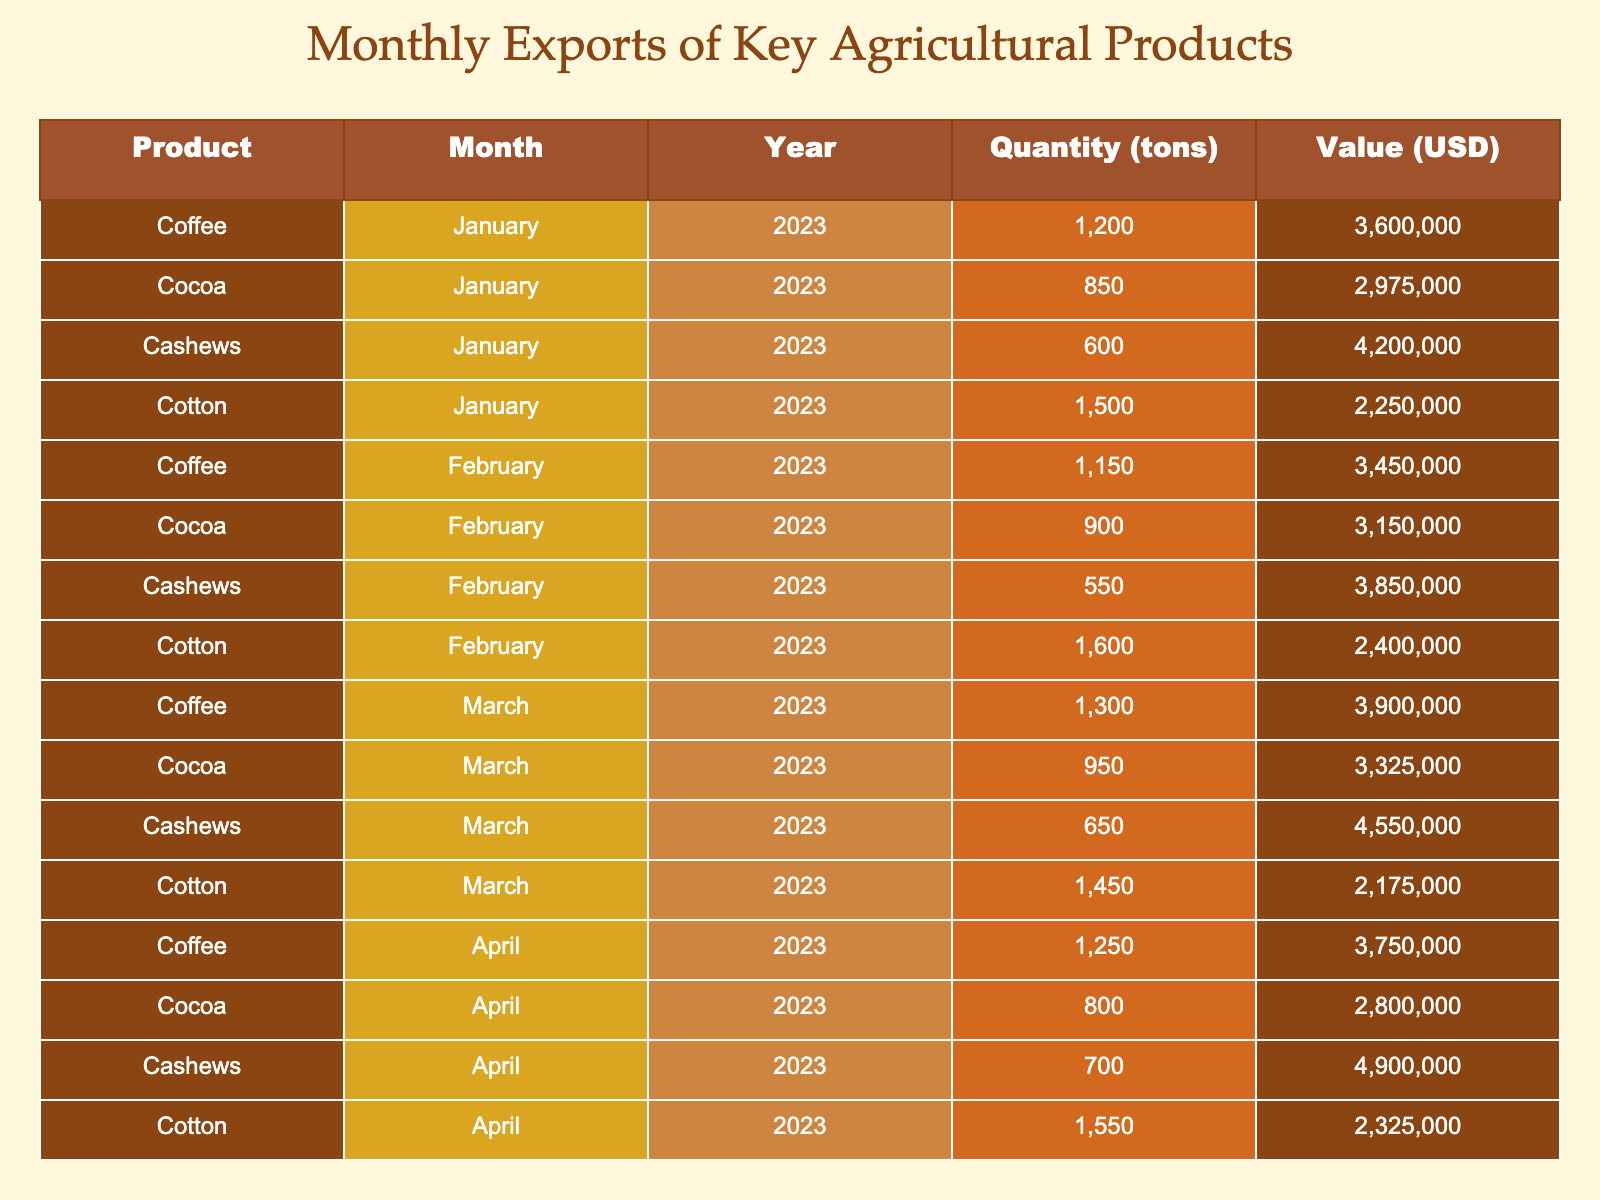What was the total quantity of coffee exported in January 2023? The quantity of coffee exported in January 2023 is listed as 1200 tons.
Answer: 1200 tons What was the total value of cashews exported in February 2023? The value of cashews exported in February 2023 is shown as 3850000 USD.
Answer: 3850000 USD Which month had the highest export value for cocoa? By comparing the value of cocoa across the months, March 2023 shows the highest value at 3325000 USD.
Answer: March 2023 What was the average quantity of cotton exported from January to May 2023? The quantities for cotton are 1500, 1600, 1450, 1550, and 1400. Summing these gives 1500 + 1600 + 1450 + 1550 + 1400 = 7500 tons, and averaging gives 7500 / 5 = 1500 tons.
Answer: 1500 tons Did cashew exports increase from January to May 2023? Observing the monthly cashew quantities: 600 in January, 550 in February, 650 in March, 700 in April, and 580 in May, there is variation, but the exports do not consistently increase; they rise from March to April.
Answer: No What is the total value of all coffee exports from January to April 2023? Adding the values for coffee from these months: 3600000 + 3450000 + 3900000 + 3750000 = 14700000 USD.
Answer: 14700000 USD Which product had the highest total quantity exported over the five months? The total quantities for each product are: Coffee = 1200 + 1150 + 1300 + 1250 + 1100 = 6050 tons, Cocoa = 850 + 900 + 950 + 800 + 920 = 4420 tons, Cashews = 600 + 550 + 650 + 700 + 580 = 3080 tons, Cotton = 1500 + 1600 + 1450 + 1550 + 1400 = 7500 tons. Therefore, cotton had the highest total with 7500 tons.
Answer: Cotton In which month were the exports of all products combined at their lowest? By summing up the exports for each product by month, we find: January = 1200 + 850 + 600 + 1500 = 4100 tons, February = 1150 + 900 + 550 + 1600 = 4150 tons, March = 1300 + 950 + 650 + 1450 = 4350 tons, April = 1250 + 800 + 700 + 1550 = 4250 tons, May = 1100 + 920 + 580 + 1400 = 4000 tons. The lowest combined exports were in May with 4000 tons.
Answer: May What was the difference in value between cocoa exports in February and April 2023? The value for cocoa in February is 3150000 USD and in April is 2800000 USD. The difference is 3150000 - 2800000 = 350000 USD.
Answer: 350000 USD Which product had the least consistent monthly exports over the analyzed period? Analyzing the monthly values: Cashew exports fluctuated with a drop in February and May, making their exports less consistent than others, such as coffee and cotton which show more stable trends.
Answer: Cashews 